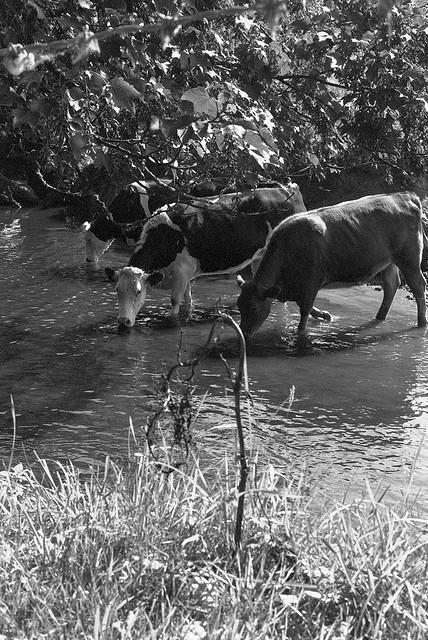How many cows?
Give a very brief answer. 3. How many cows can you see?
Give a very brief answer. 3. 